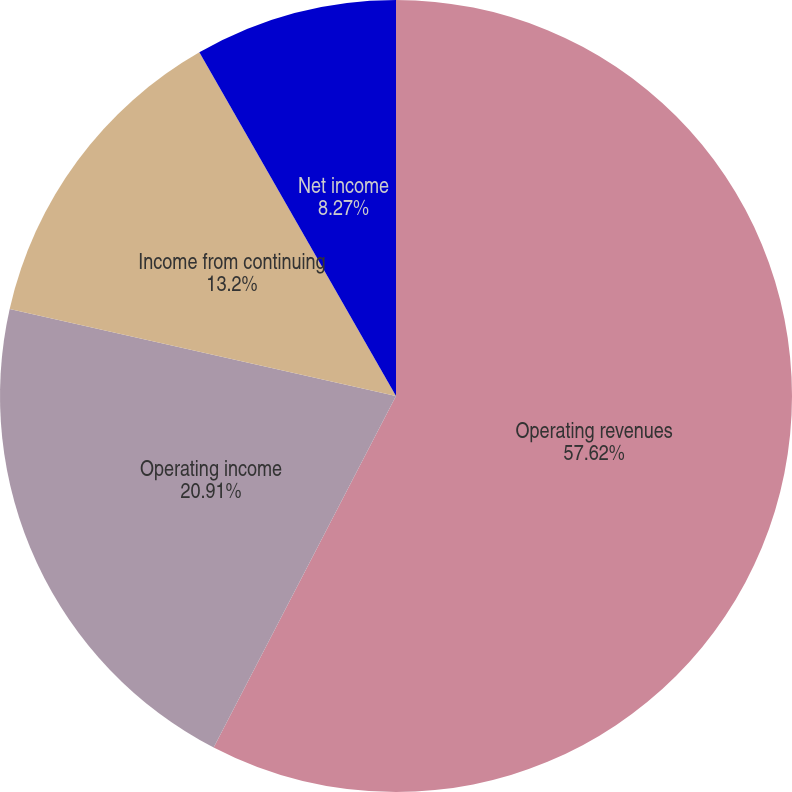Convert chart to OTSL. <chart><loc_0><loc_0><loc_500><loc_500><pie_chart><fcel>Operating revenues<fcel>Operating income<fcel>Income from continuing<fcel>Net income<nl><fcel>57.61%<fcel>20.91%<fcel>13.2%<fcel>8.27%<nl></chart> 